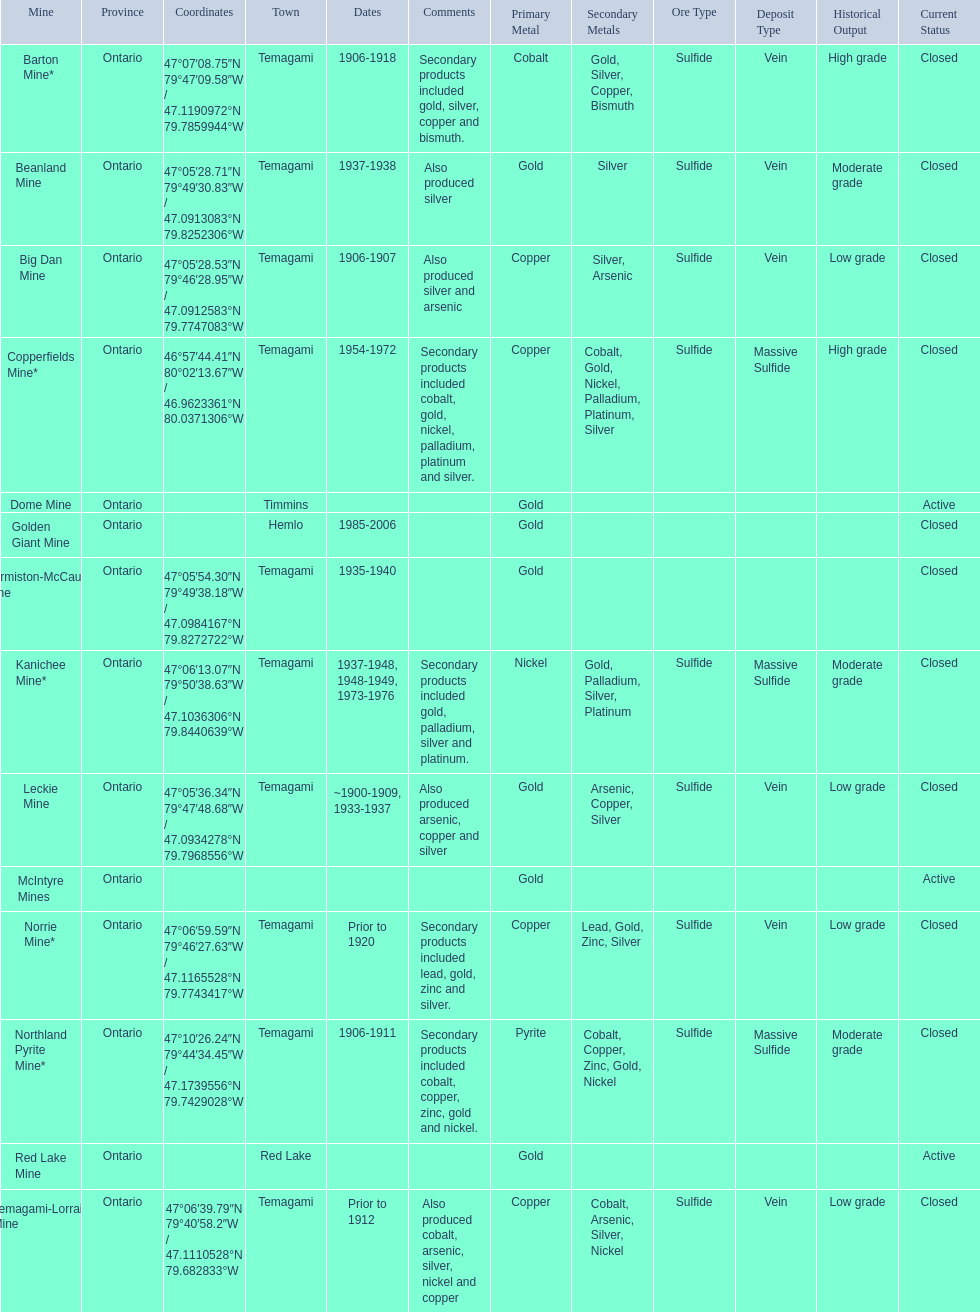Name a gold mine that was open at least 10 years. Barton Mine. 